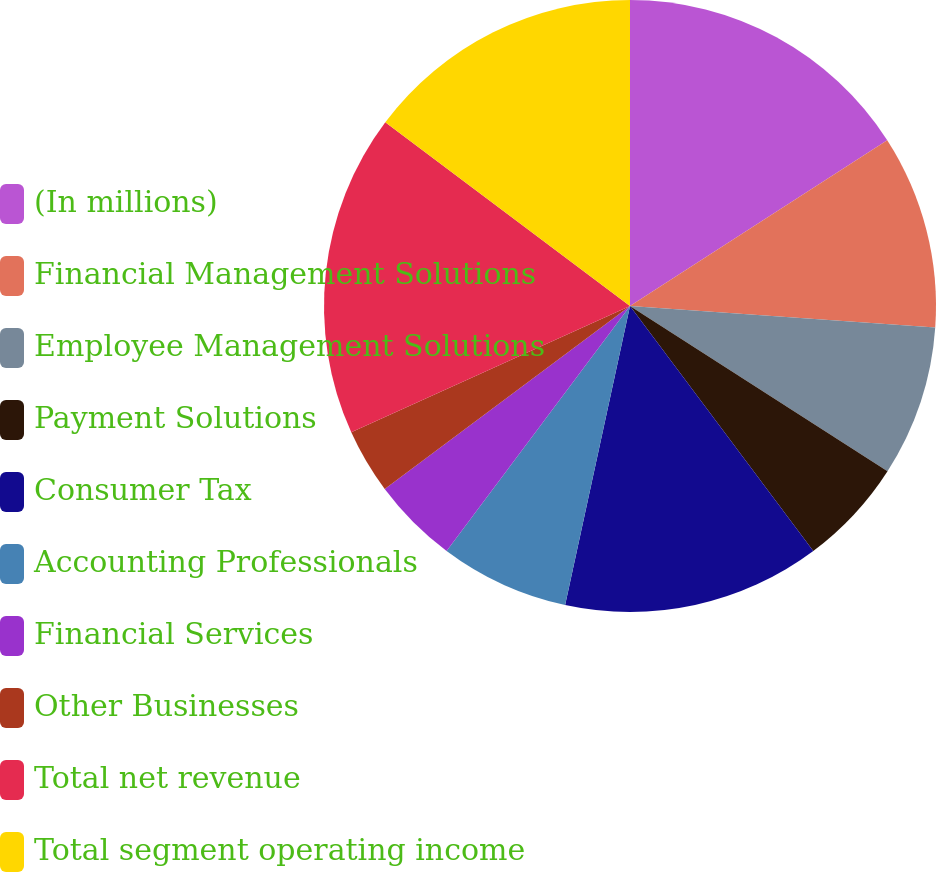Convert chart. <chart><loc_0><loc_0><loc_500><loc_500><pie_chart><fcel>(In millions)<fcel>Financial Management Solutions<fcel>Employee Management Solutions<fcel>Payment Solutions<fcel>Consumer Tax<fcel>Accounting Professionals<fcel>Financial Services<fcel>Other Businesses<fcel>Total net revenue<fcel>Total segment operating income<nl><fcel>15.89%<fcel>10.23%<fcel>7.96%<fcel>5.7%<fcel>13.62%<fcel>6.83%<fcel>4.57%<fcel>3.43%<fcel>17.02%<fcel>14.75%<nl></chart> 